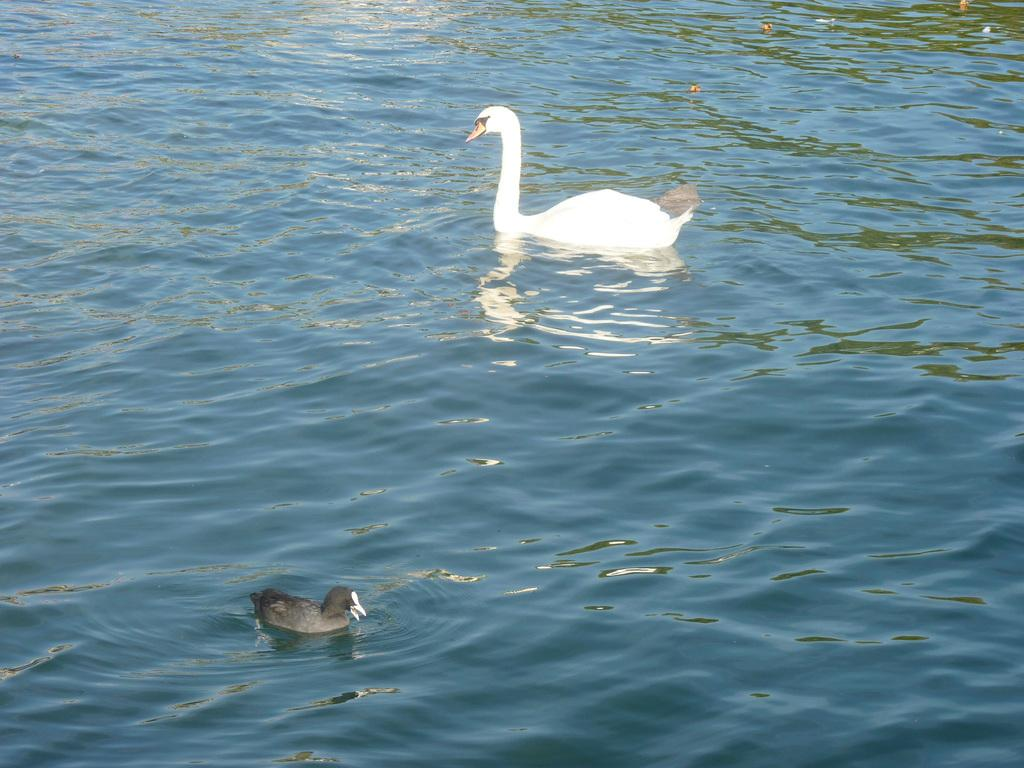What animals are present in the image? There are swans in the picture. Where are the swans located? The swans are in the water. What type of bat can be seen flying near the swans in the image? There is no bat present in the image; it only features swans in the water. What type of gate can be seen surrounding the swans in the image? There is no gate present in the image; the swans are in the water without any enclosure. 